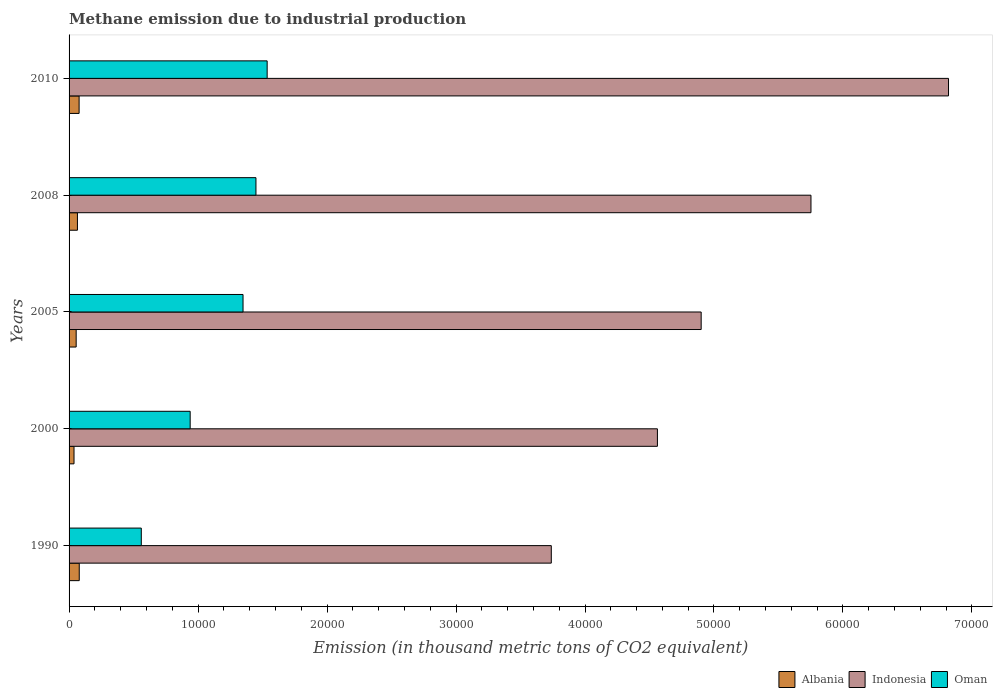How many bars are there on the 4th tick from the top?
Offer a very short reply. 3. How many bars are there on the 2nd tick from the bottom?
Your answer should be very brief. 3. What is the amount of methane emitted in Indonesia in 2008?
Offer a terse response. 5.75e+04. Across all years, what is the maximum amount of methane emitted in Albania?
Offer a terse response. 789.5. Across all years, what is the minimum amount of methane emitted in Indonesia?
Make the answer very short. 3.74e+04. In which year was the amount of methane emitted in Oman maximum?
Provide a succinct answer. 2010. What is the total amount of methane emitted in Albania in the graph?
Provide a succinct answer. 3151.1. What is the difference between the amount of methane emitted in Indonesia in 1990 and that in 2008?
Offer a terse response. -2.01e+04. What is the difference between the amount of methane emitted in Albania in 2005 and the amount of methane emitted in Indonesia in 2008?
Make the answer very short. -5.70e+04. What is the average amount of methane emitted in Oman per year?
Provide a short and direct response. 1.17e+04. In the year 2005, what is the difference between the amount of methane emitted in Albania and amount of methane emitted in Indonesia?
Give a very brief answer. -4.85e+04. What is the ratio of the amount of methane emitted in Albania in 2008 to that in 2010?
Your response must be concise. 0.83. Is the amount of methane emitted in Oman in 2008 less than that in 2010?
Your response must be concise. Yes. Is the difference between the amount of methane emitted in Albania in 1990 and 2010 greater than the difference between the amount of methane emitted in Indonesia in 1990 and 2010?
Ensure brevity in your answer.  Yes. What is the difference between the highest and the second highest amount of methane emitted in Albania?
Offer a very short reply. 11.3. What is the difference between the highest and the lowest amount of methane emitted in Albania?
Provide a short and direct response. 406.1. Is the sum of the amount of methane emitted in Oman in 2008 and 2010 greater than the maximum amount of methane emitted in Indonesia across all years?
Your answer should be compact. No. What does the 1st bar from the top in 2008 represents?
Ensure brevity in your answer.  Oman. What does the 1st bar from the bottom in 2005 represents?
Make the answer very short. Albania. How many bars are there?
Your answer should be compact. 15. How many years are there in the graph?
Your answer should be very brief. 5. Are the values on the major ticks of X-axis written in scientific E-notation?
Provide a short and direct response. No. Does the graph contain grids?
Provide a short and direct response. No. What is the title of the graph?
Your answer should be very brief. Methane emission due to industrial production. What is the label or title of the X-axis?
Make the answer very short. Emission (in thousand metric tons of CO2 equivalent). What is the label or title of the Y-axis?
Your response must be concise. Years. What is the Emission (in thousand metric tons of CO2 equivalent) of Albania in 1990?
Offer a terse response. 789.5. What is the Emission (in thousand metric tons of CO2 equivalent) of Indonesia in 1990?
Give a very brief answer. 3.74e+04. What is the Emission (in thousand metric tons of CO2 equivalent) of Oman in 1990?
Your response must be concise. 5599.6. What is the Emission (in thousand metric tons of CO2 equivalent) of Albania in 2000?
Offer a terse response. 383.4. What is the Emission (in thousand metric tons of CO2 equivalent) in Indonesia in 2000?
Offer a terse response. 4.56e+04. What is the Emission (in thousand metric tons of CO2 equivalent) in Oman in 2000?
Offer a terse response. 9388.4. What is the Emission (in thousand metric tons of CO2 equivalent) of Albania in 2005?
Provide a succinct answer. 550.9. What is the Emission (in thousand metric tons of CO2 equivalent) in Indonesia in 2005?
Offer a very short reply. 4.90e+04. What is the Emission (in thousand metric tons of CO2 equivalent) of Oman in 2005?
Offer a terse response. 1.35e+04. What is the Emission (in thousand metric tons of CO2 equivalent) in Albania in 2008?
Your answer should be very brief. 649.1. What is the Emission (in thousand metric tons of CO2 equivalent) in Indonesia in 2008?
Keep it short and to the point. 5.75e+04. What is the Emission (in thousand metric tons of CO2 equivalent) of Oman in 2008?
Keep it short and to the point. 1.45e+04. What is the Emission (in thousand metric tons of CO2 equivalent) in Albania in 2010?
Ensure brevity in your answer.  778.2. What is the Emission (in thousand metric tons of CO2 equivalent) of Indonesia in 2010?
Ensure brevity in your answer.  6.82e+04. What is the Emission (in thousand metric tons of CO2 equivalent) in Oman in 2010?
Your response must be concise. 1.54e+04. Across all years, what is the maximum Emission (in thousand metric tons of CO2 equivalent) in Albania?
Provide a succinct answer. 789.5. Across all years, what is the maximum Emission (in thousand metric tons of CO2 equivalent) of Indonesia?
Offer a very short reply. 6.82e+04. Across all years, what is the maximum Emission (in thousand metric tons of CO2 equivalent) of Oman?
Your answer should be compact. 1.54e+04. Across all years, what is the minimum Emission (in thousand metric tons of CO2 equivalent) of Albania?
Your response must be concise. 383.4. Across all years, what is the minimum Emission (in thousand metric tons of CO2 equivalent) in Indonesia?
Offer a very short reply. 3.74e+04. Across all years, what is the minimum Emission (in thousand metric tons of CO2 equivalent) in Oman?
Keep it short and to the point. 5599.6. What is the total Emission (in thousand metric tons of CO2 equivalent) of Albania in the graph?
Your answer should be compact. 3151.1. What is the total Emission (in thousand metric tons of CO2 equivalent) in Indonesia in the graph?
Ensure brevity in your answer.  2.58e+05. What is the total Emission (in thousand metric tons of CO2 equivalent) of Oman in the graph?
Your answer should be very brief. 5.83e+04. What is the difference between the Emission (in thousand metric tons of CO2 equivalent) in Albania in 1990 and that in 2000?
Your response must be concise. 406.1. What is the difference between the Emission (in thousand metric tons of CO2 equivalent) of Indonesia in 1990 and that in 2000?
Your answer should be very brief. -8228.1. What is the difference between the Emission (in thousand metric tons of CO2 equivalent) in Oman in 1990 and that in 2000?
Ensure brevity in your answer.  -3788.8. What is the difference between the Emission (in thousand metric tons of CO2 equivalent) of Albania in 1990 and that in 2005?
Make the answer very short. 238.6. What is the difference between the Emission (in thousand metric tons of CO2 equivalent) in Indonesia in 1990 and that in 2005?
Your answer should be compact. -1.16e+04. What is the difference between the Emission (in thousand metric tons of CO2 equivalent) of Oman in 1990 and that in 2005?
Keep it short and to the point. -7887.8. What is the difference between the Emission (in thousand metric tons of CO2 equivalent) of Albania in 1990 and that in 2008?
Offer a terse response. 140.4. What is the difference between the Emission (in thousand metric tons of CO2 equivalent) in Indonesia in 1990 and that in 2008?
Keep it short and to the point. -2.01e+04. What is the difference between the Emission (in thousand metric tons of CO2 equivalent) of Oman in 1990 and that in 2008?
Your answer should be compact. -8889.6. What is the difference between the Emission (in thousand metric tons of CO2 equivalent) in Albania in 1990 and that in 2010?
Ensure brevity in your answer.  11.3. What is the difference between the Emission (in thousand metric tons of CO2 equivalent) of Indonesia in 1990 and that in 2010?
Offer a terse response. -3.08e+04. What is the difference between the Emission (in thousand metric tons of CO2 equivalent) in Oman in 1990 and that in 2010?
Offer a very short reply. -9757.6. What is the difference between the Emission (in thousand metric tons of CO2 equivalent) of Albania in 2000 and that in 2005?
Make the answer very short. -167.5. What is the difference between the Emission (in thousand metric tons of CO2 equivalent) in Indonesia in 2000 and that in 2005?
Keep it short and to the point. -3391.6. What is the difference between the Emission (in thousand metric tons of CO2 equivalent) of Oman in 2000 and that in 2005?
Make the answer very short. -4099. What is the difference between the Emission (in thousand metric tons of CO2 equivalent) of Albania in 2000 and that in 2008?
Offer a very short reply. -265.7. What is the difference between the Emission (in thousand metric tons of CO2 equivalent) in Indonesia in 2000 and that in 2008?
Make the answer very short. -1.19e+04. What is the difference between the Emission (in thousand metric tons of CO2 equivalent) of Oman in 2000 and that in 2008?
Keep it short and to the point. -5100.8. What is the difference between the Emission (in thousand metric tons of CO2 equivalent) in Albania in 2000 and that in 2010?
Provide a succinct answer. -394.8. What is the difference between the Emission (in thousand metric tons of CO2 equivalent) of Indonesia in 2000 and that in 2010?
Provide a succinct answer. -2.26e+04. What is the difference between the Emission (in thousand metric tons of CO2 equivalent) in Oman in 2000 and that in 2010?
Make the answer very short. -5968.8. What is the difference between the Emission (in thousand metric tons of CO2 equivalent) of Albania in 2005 and that in 2008?
Ensure brevity in your answer.  -98.2. What is the difference between the Emission (in thousand metric tons of CO2 equivalent) of Indonesia in 2005 and that in 2008?
Keep it short and to the point. -8512.6. What is the difference between the Emission (in thousand metric tons of CO2 equivalent) of Oman in 2005 and that in 2008?
Offer a terse response. -1001.8. What is the difference between the Emission (in thousand metric tons of CO2 equivalent) of Albania in 2005 and that in 2010?
Your response must be concise. -227.3. What is the difference between the Emission (in thousand metric tons of CO2 equivalent) in Indonesia in 2005 and that in 2010?
Offer a very short reply. -1.92e+04. What is the difference between the Emission (in thousand metric tons of CO2 equivalent) in Oman in 2005 and that in 2010?
Ensure brevity in your answer.  -1869.8. What is the difference between the Emission (in thousand metric tons of CO2 equivalent) of Albania in 2008 and that in 2010?
Provide a short and direct response. -129.1. What is the difference between the Emission (in thousand metric tons of CO2 equivalent) of Indonesia in 2008 and that in 2010?
Your response must be concise. -1.07e+04. What is the difference between the Emission (in thousand metric tons of CO2 equivalent) in Oman in 2008 and that in 2010?
Make the answer very short. -868. What is the difference between the Emission (in thousand metric tons of CO2 equivalent) of Albania in 1990 and the Emission (in thousand metric tons of CO2 equivalent) of Indonesia in 2000?
Keep it short and to the point. -4.48e+04. What is the difference between the Emission (in thousand metric tons of CO2 equivalent) in Albania in 1990 and the Emission (in thousand metric tons of CO2 equivalent) in Oman in 2000?
Provide a short and direct response. -8598.9. What is the difference between the Emission (in thousand metric tons of CO2 equivalent) of Indonesia in 1990 and the Emission (in thousand metric tons of CO2 equivalent) of Oman in 2000?
Provide a short and direct response. 2.80e+04. What is the difference between the Emission (in thousand metric tons of CO2 equivalent) of Albania in 1990 and the Emission (in thousand metric tons of CO2 equivalent) of Indonesia in 2005?
Provide a short and direct response. -4.82e+04. What is the difference between the Emission (in thousand metric tons of CO2 equivalent) of Albania in 1990 and the Emission (in thousand metric tons of CO2 equivalent) of Oman in 2005?
Offer a terse response. -1.27e+04. What is the difference between the Emission (in thousand metric tons of CO2 equivalent) of Indonesia in 1990 and the Emission (in thousand metric tons of CO2 equivalent) of Oman in 2005?
Provide a short and direct response. 2.39e+04. What is the difference between the Emission (in thousand metric tons of CO2 equivalent) in Albania in 1990 and the Emission (in thousand metric tons of CO2 equivalent) in Indonesia in 2008?
Ensure brevity in your answer.  -5.67e+04. What is the difference between the Emission (in thousand metric tons of CO2 equivalent) in Albania in 1990 and the Emission (in thousand metric tons of CO2 equivalent) in Oman in 2008?
Your response must be concise. -1.37e+04. What is the difference between the Emission (in thousand metric tons of CO2 equivalent) in Indonesia in 1990 and the Emission (in thousand metric tons of CO2 equivalent) in Oman in 2008?
Your response must be concise. 2.29e+04. What is the difference between the Emission (in thousand metric tons of CO2 equivalent) in Albania in 1990 and the Emission (in thousand metric tons of CO2 equivalent) in Indonesia in 2010?
Make the answer very short. -6.74e+04. What is the difference between the Emission (in thousand metric tons of CO2 equivalent) of Albania in 1990 and the Emission (in thousand metric tons of CO2 equivalent) of Oman in 2010?
Your answer should be very brief. -1.46e+04. What is the difference between the Emission (in thousand metric tons of CO2 equivalent) of Indonesia in 1990 and the Emission (in thousand metric tons of CO2 equivalent) of Oman in 2010?
Offer a very short reply. 2.20e+04. What is the difference between the Emission (in thousand metric tons of CO2 equivalent) of Albania in 2000 and the Emission (in thousand metric tons of CO2 equivalent) of Indonesia in 2005?
Provide a short and direct response. -4.86e+04. What is the difference between the Emission (in thousand metric tons of CO2 equivalent) of Albania in 2000 and the Emission (in thousand metric tons of CO2 equivalent) of Oman in 2005?
Give a very brief answer. -1.31e+04. What is the difference between the Emission (in thousand metric tons of CO2 equivalent) in Indonesia in 2000 and the Emission (in thousand metric tons of CO2 equivalent) in Oman in 2005?
Ensure brevity in your answer.  3.21e+04. What is the difference between the Emission (in thousand metric tons of CO2 equivalent) of Albania in 2000 and the Emission (in thousand metric tons of CO2 equivalent) of Indonesia in 2008?
Make the answer very short. -5.71e+04. What is the difference between the Emission (in thousand metric tons of CO2 equivalent) in Albania in 2000 and the Emission (in thousand metric tons of CO2 equivalent) in Oman in 2008?
Give a very brief answer. -1.41e+04. What is the difference between the Emission (in thousand metric tons of CO2 equivalent) of Indonesia in 2000 and the Emission (in thousand metric tons of CO2 equivalent) of Oman in 2008?
Offer a very short reply. 3.11e+04. What is the difference between the Emission (in thousand metric tons of CO2 equivalent) in Albania in 2000 and the Emission (in thousand metric tons of CO2 equivalent) in Indonesia in 2010?
Your response must be concise. -6.78e+04. What is the difference between the Emission (in thousand metric tons of CO2 equivalent) in Albania in 2000 and the Emission (in thousand metric tons of CO2 equivalent) in Oman in 2010?
Your answer should be very brief. -1.50e+04. What is the difference between the Emission (in thousand metric tons of CO2 equivalent) in Indonesia in 2000 and the Emission (in thousand metric tons of CO2 equivalent) in Oman in 2010?
Ensure brevity in your answer.  3.03e+04. What is the difference between the Emission (in thousand metric tons of CO2 equivalent) of Albania in 2005 and the Emission (in thousand metric tons of CO2 equivalent) of Indonesia in 2008?
Provide a short and direct response. -5.70e+04. What is the difference between the Emission (in thousand metric tons of CO2 equivalent) of Albania in 2005 and the Emission (in thousand metric tons of CO2 equivalent) of Oman in 2008?
Offer a very short reply. -1.39e+04. What is the difference between the Emission (in thousand metric tons of CO2 equivalent) of Indonesia in 2005 and the Emission (in thousand metric tons of CO2 equivalent) of Oman in 2008?
Your response must be concise. 3.45e+04. What is the difference between the Emission (in thousand metric tons of CO2 equivalent) in Albania in 2005 and the Emission (in thousand metric tons of CO2 equivalent) in Indonesia in 2010?
Make the answer very short. -6.76e+04. What is the difference between the Emission (in thousand metric tons of CO2 equivalent) in Albania in 2005 and the Emission (in thousand metric tons of CO2 equivalent) in Oman in 2010?
Offer a very short reply. -1.48e+04. What is the difference between the Emission (in thousand metric tons of CO2 equivalent) in Indonesia in 2005 and the Emission (in thousand metric tons of CO2 equivalent) in Oman in 2010?
Your answer should be compact. 3.36e+04. What is the difference between the Emission (in thousand metric tons of CO2 equivalent) in Albania in 2008 and the Emission (in thousand metric tons of CO2 equivalent) in Indonesia in 2010?
Ensure brevity in your answer.  -6.75e+04. What is the difference between the Emission (in thousand metric tons of CO2 equivalent) of Albania in 2008 and the Emission (in thousand metric tons of CO2 equivalent) of Oman in 2010?
Ensure brevity in your answer.  -1.47e+04. What is the difference between the Emission (in thousand metric tons of CO2 equivalent) in Indonesia in 2008 and the Emission (in thousand metric tons of CO2 equivalent) in Oman in 2010?
Your response must be concise. 4.22e+04. What is the average Emission (in thousand metric tons of CO2 equivalent) in Albania per year?
Provide a succinct answer. 630.22. What is the average Emission (in thousand metric tons of CO2 equivalent) of Indonesia per year?
Your answer should be compact. 5.15e+04. What is the average Emission (in thousand metric tons of CO2 equivalent) of Oman per year?
Provide a succinct answer. 1.17e+04. In the year 1990, what is the difference between the Emission (in thousand metric tons of CO2 equivalent) of Albania and Emission (in thousand metric tons of CO2 equivalent) of Indonesia?
Your answer should be compact. -3.66e+04. In the year 1990, what is the difference between the Emission (in thousand metric tons of CO2 equivalent) in Albania and Emission (in thousand metric tons of CO2 equivalent) in Oman?
Your response must be concise. -4810.1. In the year 1990, what is the difference between the Emission (in thousand metric tons of CO2 equivalent) in Indonesia and Emission (in thousand metric tons of CO2 equivalent) in Oman?
Keep it short and to the point. 3.18e+04. In the year 2000, what is the difference between the Emission (in thousand metric tons of CO2 equivalent) of Albania and Emission (in thousand metric tons of CO2 equivalent) of Indonesia?
Give a very brief answer. -4.52e+04. In the year 2000, what is the difference between the Emission (in thousand metric tons of CO2 equivalent) of Albania and Emission (in thousand metric tons of CO2 equivalent) of Oman?
Offer a very short reply. -9005. In the year 2000, what is the difference between the Emission (in thousand metric tons of CO2 equivalent) of Indonesia and Emission (in thousand metric tons of CO2 equivalent) of Oman?
Offer a very short reply. 3.62e+04. In the year 2005, what is the difference between the Emission (in thousand metric tons of CO2 equivalent) of Albania and Emission (in thousand metric tons of CO2 equivalent) of Indonesia?
Give a very brief answer. -4.85e+04. In the year 2005, what is the difference between the Emission (in thousand metric tons of CO2 equivalent) in Albania and Emission (in thousand metric tons of CO2 equivalent) in Oman?
Keep it short and to the point. -1.29e+04. In the year 2005, what is the difference between the Emission (in thousand metric tons of CO2 equivalent) in Indonesia and Emission (in thousand metric tons of CO2 equivalent) in Oman?
Provide a succinct answer. 3.55e+04. In the year 2008, what is the difference between the Emission (in thousand metric tons of CO2 equivalent) in Albania and Emission (in thousand metric tons of CO2 equivalent) in Indonesia?
Give a very brief answer. -5.69e+04. In the year 2008, what is the difference between the Emission (in thousand metric tons of CO2 equivalent) in Albania and Emission (in thousand metric tons of CO2 equivalent) in Oman?
Your answer should be very brief. -1.38e+04. In the year 2008, what is the difference between the Emission (in thousand metric tons of CO2 equivalent) of Indonesia and Emission (in thousand metric tons of CO2 equivalent) of Oman?
Offer a very short reply. 4.30e+04. In the year 2010, what is the difference between the Emission (in thousand metric tons of CO2 equivalent) in Albania and Emission (in thousand metric tons of CO2 equivalent) in Indonesia?
Provide a succinct answer. -6.74e+04. In the year 2010, what is the difference between the Emission (in thousand metric tons of CO2 equivalent) of Albania and Emission (in thousand metric tons of CO2 equivalent) of Oman?
Keep it short and to the point. -1.46e+04. In the year 2010, what is the difference between the Emission (in thousand metric tons of CO2 equivalent) in Indonesia and Emission (in thousand metric tons of CO2 equivalent) in Oman?
Offer a terse response. 5.28e+04. What is the ratio of the Emission (in thousand metric tons of CO2 equivalent) in Albania in 1990 to that in 2000?
Your response must be concise. 2.06. What is the ratio of the Emission (in thousand metric tons of CO2 equivalent) in Indonesia in 1990 to that in 2000?
Your answer should be compact. 0.82. What is the ratio of the Emission (in thousand metric tons of CO2 equivalent) in Oman in 1990 to that in 2000?
Your answer should be compact. 0.6. What is the ratio of the Emission (in thousand metric tons of CO2 equivalent) in Albania in 1990 to that in 2005?
Offer a terse response. 1.43. What is the ratio of the Emission (in thousand metric tons of CO2 equivalent) of Indonesia in 1990 to that in 2005?
Provide a short and direct response. 0.76. What is the ratio of the Emission (in thousand metric tons of CO2 equivalent) in Oman in 1990 to that in 2005?
Give a very brief answer. 0.42. What is the ratio of the Emission (in thousand metric tons of CO2 equivalent) in Albania in 1990 to that in 2008?
Your answer should be compact. 1.22. What is the ratio of the Emission (in thousand metric tons of CO2 equivalent) in Indonesia in 1990 to that in 2008?
Your answer should be very brief. 0.65. What is the ratio of the Emission (in thousand metric tons of CO2 equivalent) in Oman in 1990 to that in 2008?
Offer a terse response. 0.39. What is the ratio of the Emission (in thousand metric tons of CO2 equivalent) of Albania in 1990 to that in 2010?
Make the answer very short. 1.01. What is the ratio of the Emission (in thousand metric tons of CO2 equivalent) in Indonesia in 1990 to that in 2010?
Provide a succinct answer. 0.55. What is the ratio of the Emission (in thousand metric tons of CO2 equivalent) of Oman in 1990 to that in 2010?
Your answer should be compact. 0.36. What is the ratio of the Emission (in thousand metric tons of CO2 equivalent) of Albania in 2000 to that in 2005?
Ensure brevity in your answer.  0.7. What is the ratio of the Emission (in thousand metric tons of CO2 equivalent) of Indonesia in 2000 to that in 2005?
Give a very brief answer. 0.93. What is the ratio of the Emission (in thousand metric tons of CO2 equivalent) of Oman in 2000 to that in 2005?
Make the answer very short. 0.7. What is the ratio of the Emission (in thousand metric tons of CO2 equivalent) of Albania in 2000 to that in 2008?
Keep it short and to the point. 0.59. What is the ratio of the Emission (in thousand metric tons of CO2 equivalent) of Indonesia in 2000 to that in 2008?
Provide a succinct answer. 0.79. What is the ratio of the Emission (in thousand metric tons of CO2 equivalent) of Oman in 2000 to that in 2008?
Provide a short and direct response. 0.65. What is the ratio of the Emission (in thousand metric tons of CO2 equivalent) of Albania in 2000 to that in 2010?
Offer a terse response. 0.49. What is the ratio of the Emission (in thousand metric tons of CO2 equivalent) of Indonesia in 2000 to that in 2010?
Offer a terse response. 0.67. What is the ratio of the Emission (in thousand metric tons of CO2 equivalent) in Oman in 2000 to that in 2010?
Your answer should be very brief. 0.61. What is the ratio of the Emission (in thousand metric tons of CO2 equivalent) in Albania in 2005 to that in 2008?
Provide a short and direct response. 0.85. What is the ratio of the Emission (in thousand metric tons of CO2 equivalent) of Indonesia in 2005 to that in 2008?
Offer a terse response. 0.85. What is the ratio of the Emission (in thousand metric tons of CO2 equivalent) of Oman in 2005 to that in 2008?
Make the answer very short. 0.93. What is the ratio of the Emission (in thousand metric tons of CO2 equivalent) of Albania in 2005 to that in 2010?
Ensure brevity in your answer.  0.71. What is the ratio of the Emission (in thousand metric tons of CO2 equivalent) of Indonesia in 2005 to that in 2010?
Provide a short and direct response. 0.72. What is the ratio of the Emission (in thousand metric tons of CO2 equivalent) in Oman in 2005 to that in 2010?
Your answer should be very brief. 0.88. What is the ratio of the Emission (in thousand metric tons of CO2 equivalent) in Albania in 2008 to that in 2010?
Provide a succinct answer. 0.83. What is the ratio of the Emission (in thousand metric tons of CO2 equivalent) of Indonesia in 2008 to that in 2010?
Make the answer very short. 0.84. What is the ratio of the Emission (in thousand metric tons of CO2 equivalent) in Oman in 2008 to that in 2010?
Provide a short and direct response. 0.94. What is the difference between the highest and the second highest Emission (in thousand metric tons of CO2 equivalent) in Indonesia?
Keep it short and to the point. 1.07e+04. What is the difference between the highest and the second highest Emission (in thousand metric tons of CO2 equivalent) in Oman?
Ensure brevity in your answer.  868. What is the difference between the highest and the lowest Emission (in thousand metric tons of CO2 equivalent) in Albania?
Provide a short and direct response. 406.1. What is the difference between the highest and the lowest Emission (in thousand metric tons of CO2 equivalent) in Indonesia?
Provide a short and direct response. 3.08e+04. What is the difference between the highest and the lowest Emission (in thousand metric tons of CO2 equivalent) of Oman?
Provide a short and direct response. 9757.6. 